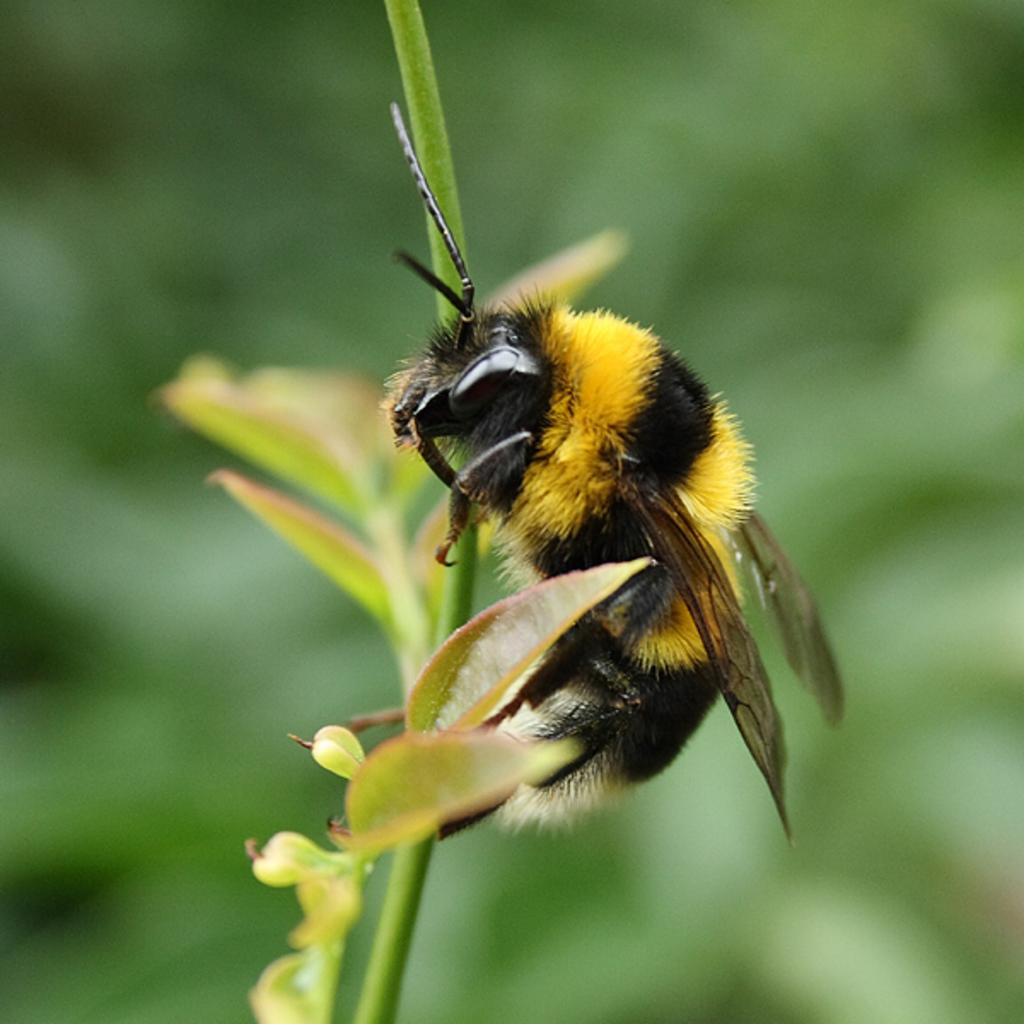What type of creature is in the image? There is an insect in the image. What colors can be seen on the insect? The insect has yellow and black coloring. Where is the insect located in the image? The insect is on a plant. What color is the background of the image? The background of the image is green. Where is the desk located in the image? There is no desk present in the image. What type of stocking is the insect wearing in the image? Insects do not wear stockings, and there is no indication of any clothing on the insect in the image. 